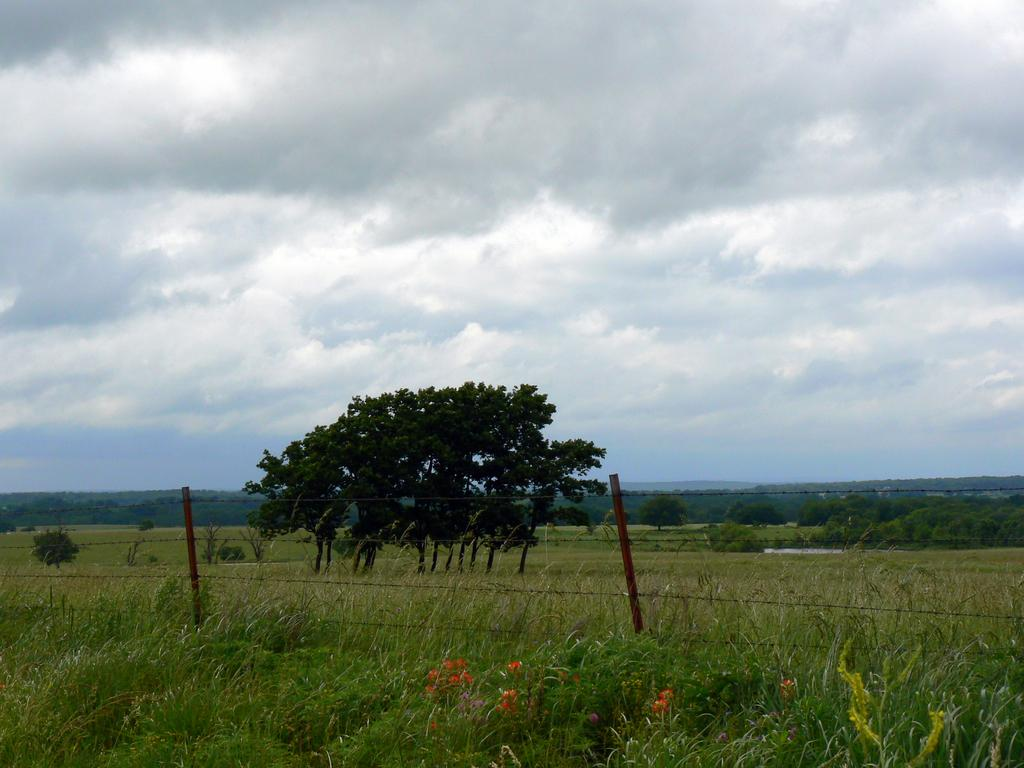What type of vegetation is on the ground in the image? There is grass on the ground in the image. What is located behind the grass? There is a fencing behind the grass. What can be seen behind the fencing? There are trees behind the fencing. What is visible in the distance in the image? There are mountains in the background of the image. What is visible at the top of the image? The sky is visible at the top of the image. Who is the manager of the farm in the image? There is no farm or manager present in the image. Can you tell me how many flights are visible in the image? There are no flights visible in the image. 